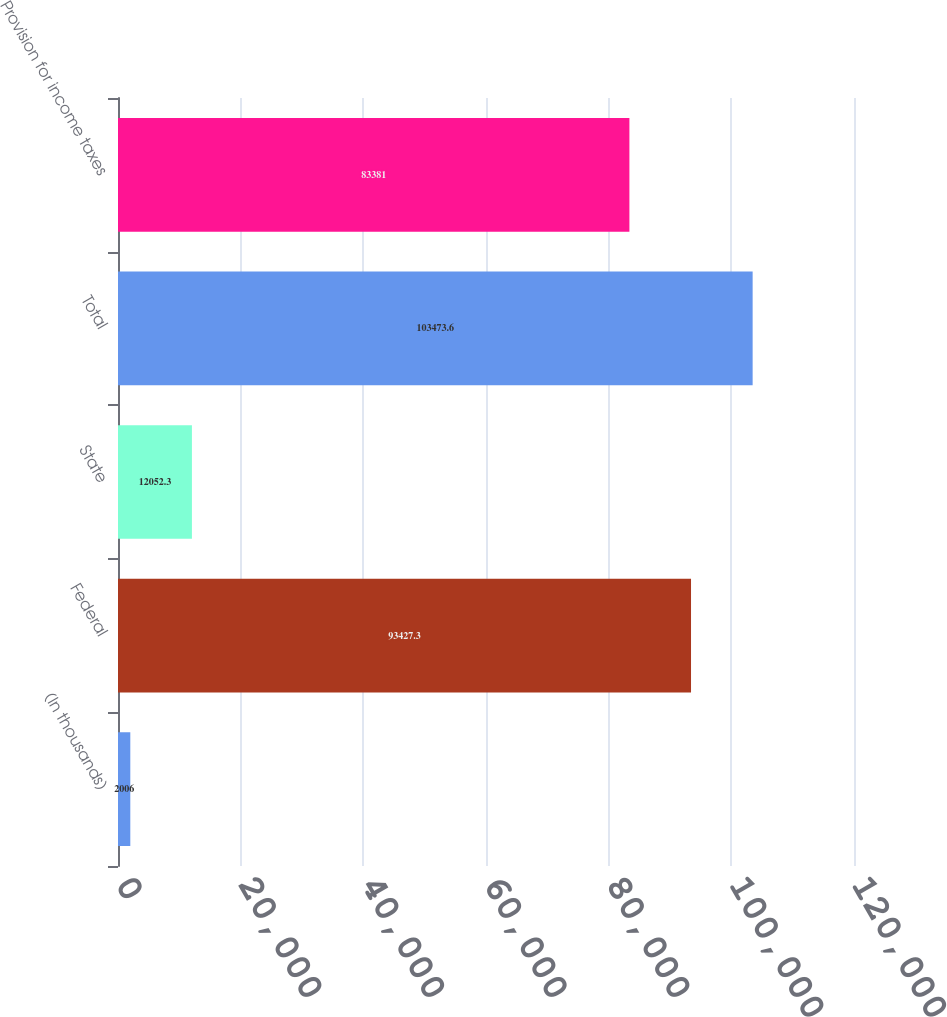<chart> <loc_0><loc_0><loc_500><loc_500><bar_chart><fcel>(In thousands)<fcel>Federal<fcel>State<fcel>Total<fcel>Provision for income taxes<nl><fcel>2006<fcel>93427.3<fcel>12052.3<fcel>103474<fcel>83381<nl></chart> 